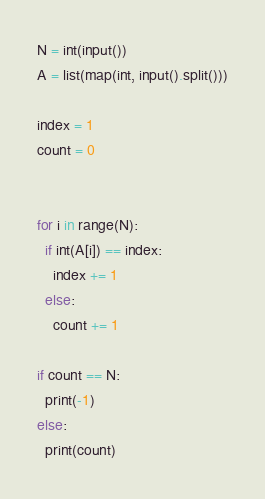Convert code to text. <code><loc_0><loc_0><loc_500><loc_500><_Python_>N = int(input())
A = list(map(int, input().split()))

index = 1
count = 0


for i in range(N):
  if int(A[i]) == index:
    index += 1
  else:
    count += 1

if count == N:
  print(-1)
else:
  print(count)</code> 